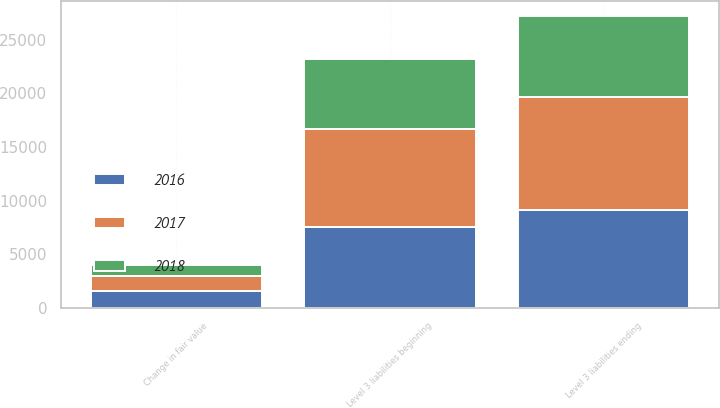Convert chart to OTSL. <chart><loc_0><loc_0><loc_500><loc_500><stacked_bar_chart><ecel><fcel>Level 3 liabilities beginning<fcel>Change in fair value<fcel>Level 3 liabilities ending<nl><fcel>2017<fcel>9153<fcel>1337<fcel>10490<nl><fcel>2016<fcel>7563<fcel>1590<fcel>9153<nl><fcel>2018<fcel>6510<fcel>1053<fcel>7563<nl></chart> 